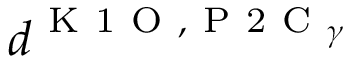<formula> <loc_0><loc_0><loc_500><loc_500>d ^ { K 1 O , P 2 C _ { \gamma } }</formula> 